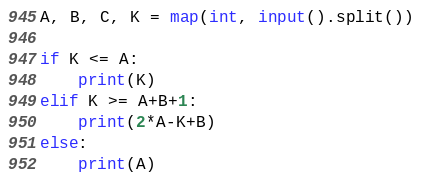Convert code to text. <code><loc_0><loc_0><loc_500><loc_500><_Python_>A, B, C, K = map(int, input().split())

if K <= A:
    print(K)
elif K >= A+B+1:
    print(2*A-K+B)
else:
    print(A)</code> 